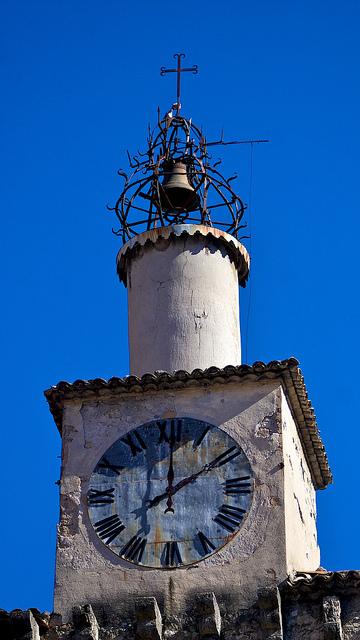Is the sky clear?
Answer briefly. Yes. Is the clock very new?
Keep it brief. No. What is on top of the clock?
Give a very brief answer. Bell. 